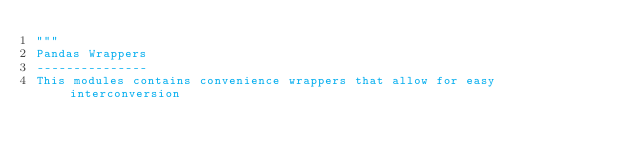<code> <loc_0><loc_0><loc_500><loc_500><_Python_>"""
Pandas Wrappers
---------------
This modules contains convenience wrappers that allow for easy interconversion</code> 